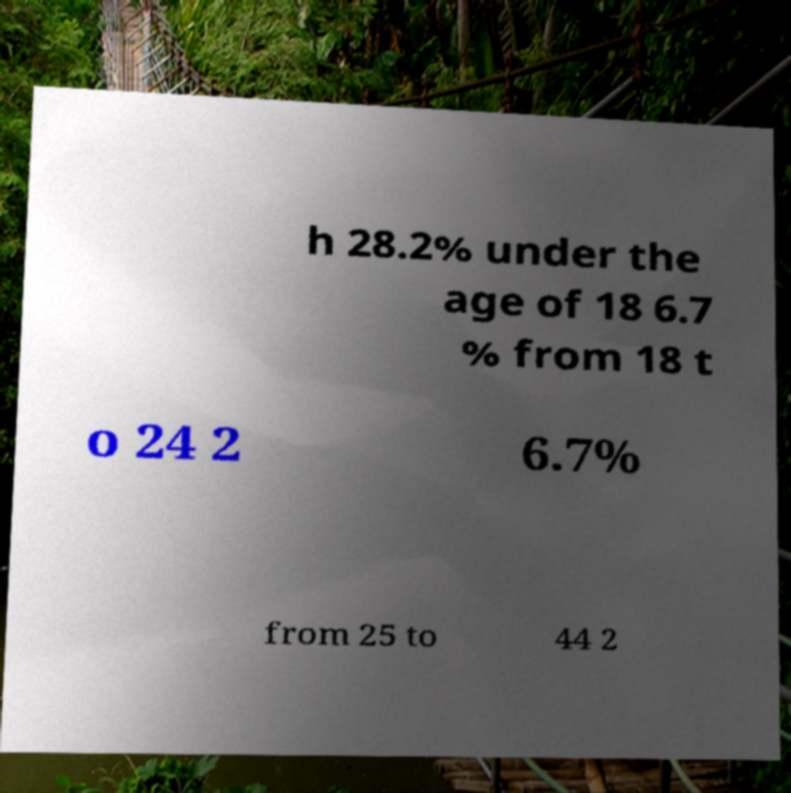Please identify and transcribe the text found in this image. h 28.2% under the age of 18 6.7 % from 18 t o 24 2 6.7% from 25 to 44 2 